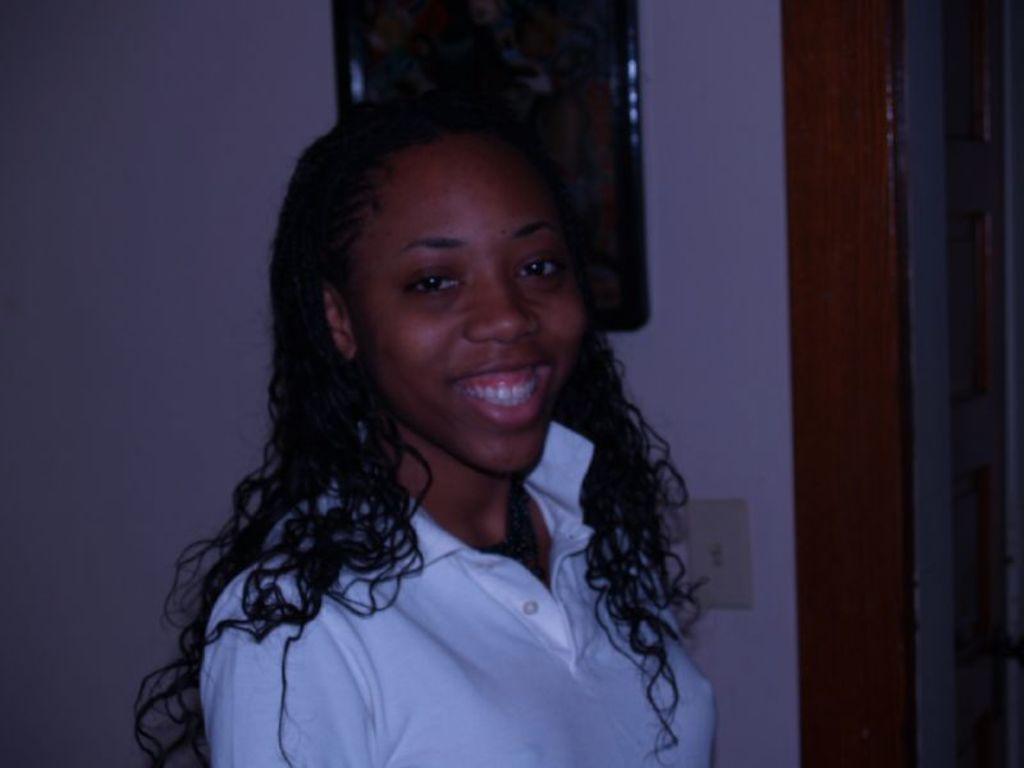Can you describe this image briefly? In the center of the image we can see the woman smiling. In the background we can see the frame attached to the plain wall. 